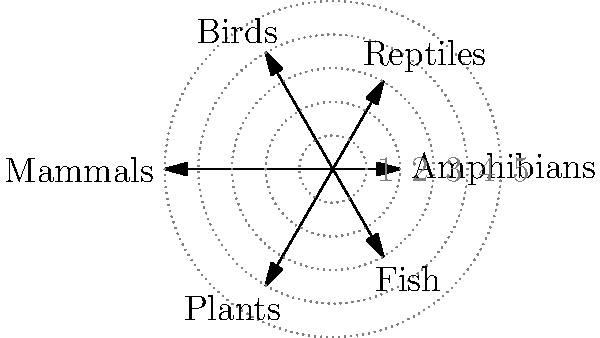The polar coordinate plot represents the distribution of various species groups in a biodiversity hotspot. Each axis represents a different species group, and the distance from the center indicates the relative abundance of species. Based on this visualization, which species group shows the highest relative abundance, and how might this information be relevant for a biodiversity conservationist concerned about bioenergy impacts? To answer this question, we need to analyze the polar coordinate plot and consider its implications for biodiversity conservation:

1. Interpret the plot:
   - Each axis represents a different species group (Amphibians, Reptiles, Birds, Mammals, Plants, Fish).
   - The distance from the center indicates the relative abundance of species in each group.

2. Identify the highest abundance:
   - Mammals have the longest axis, reaching the 5th concentric circle.
   - This indicates that mammals have the highest relative abundance among the species groups shown.

3. Relevance for a biodiversity conservationist:
   a) Habitat importance: High mammal abundance suggests the area is crucial for mammalian diversity.
   b) Ecosystem roles: Mammals often play key roles in ecosystem functioning (e.g., seed dispersal, predation).
   c) Bioenergy impact assessment: 
      - Mammal habitats might be more sensitive to land-use changes for bioenergy production.
      - Need to consider potential fragmentation of mammal habitats.
   d) Conservation priorities: 
      - While mammals show highest abundance, other groups (e.g., birds, reptiles) also show significant presence.
      - Holistic approach needed to protect overall biodiversity.
   e) Monitoring: 
      - Use mammals as potential indicator species for ecosystem health.
      - Track changes in mammal populations as bioenergy projects are implemented.

4. Bioenergy considerations:
   - Assess how bioenergy crop cultivation or biomass harvesting might affect mammal habitats and movement.
   - Evaluate potential impacts on other species groups, especially those with lower abundance.
   - Design bioenergy projects to minimize disruption to key habitats and maintain connectivity.

This visualization helps prioritize conservation efforts and guides the assessment of potential bioenergy impacts on local biodiversity.
Answer: Mammals; guides impact assessment and conservation priorities for bioenergy projects. 